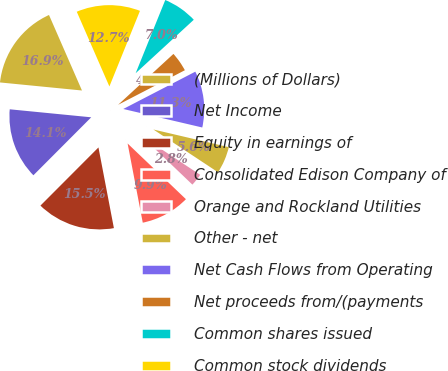Convert chart to OTSL. <chart><loc_0><loc_0><loc_500><loc_500><pie_chart><fcel>(Millions of Dollars)<fcel>Net Income<fcel>Equity in earnings of<fcel>Consolidated Edison Company of<fcel>Orange and Rockland Utilities<fcel>Other - net<fcel>Net Cash Flows from Operating<fcel>Net proceeds from/(payments<fcel>Common shares issued<fcel>Common stock dividends<nl><fcel>16.89%<fcel>14.08%<fcel>15.49%<fcel>9.86%<fcel>2.83%<fcel>5.64%<fcel>11.27%<fcel>4.23%<fcel>7.05%<fcel>12.67%<nl></chart> 